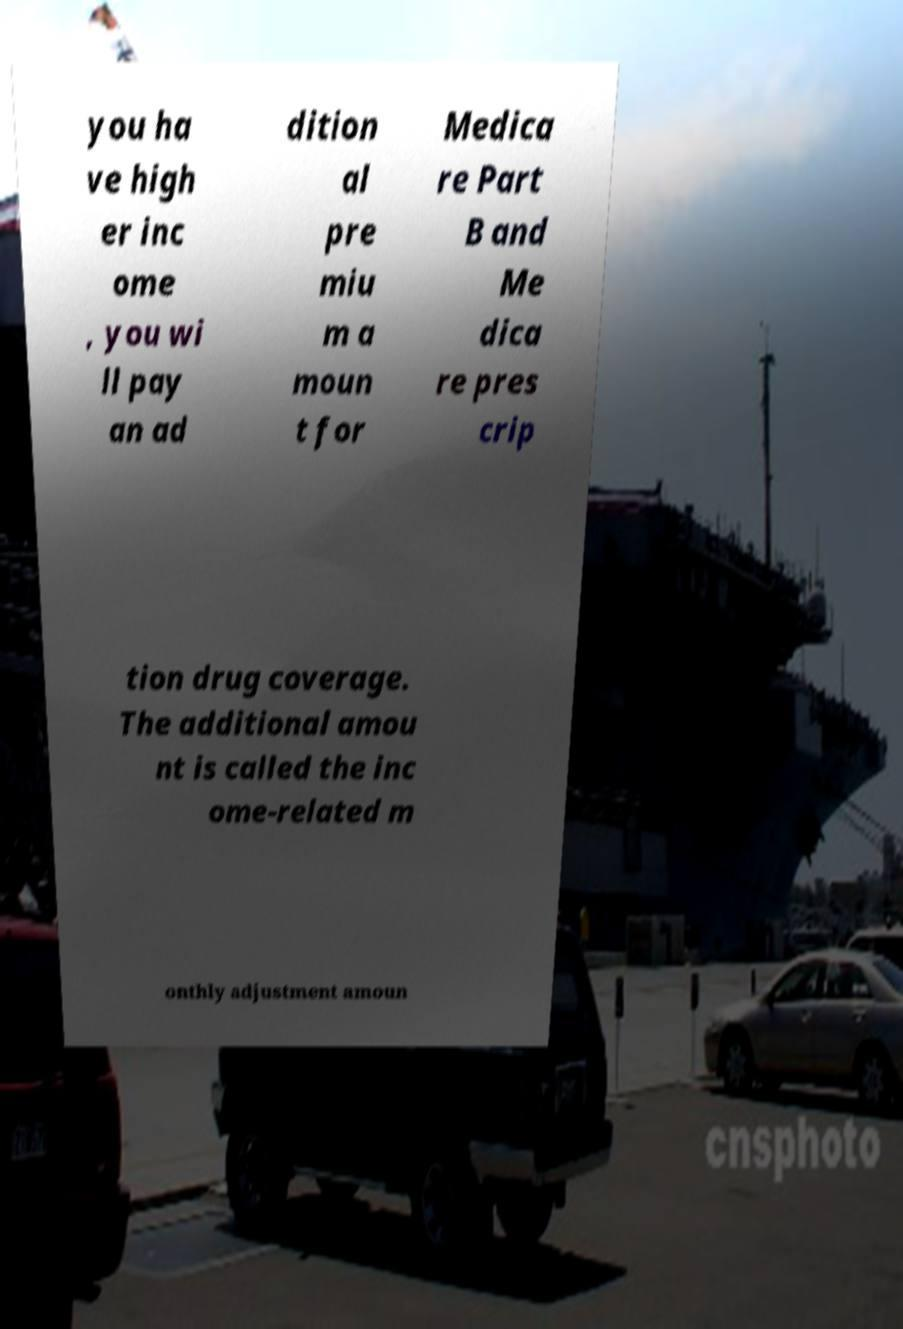I need the written content from this picture converted into text. Can you do that? you ha ve high er inc ome , you wi ll pay an ad dition al pre miu m a moun t for Medica re Part B and Me dica re pres crip tion drug coverage. The additional amou nt is called the inc ome-related m onthly adjustment amoun 